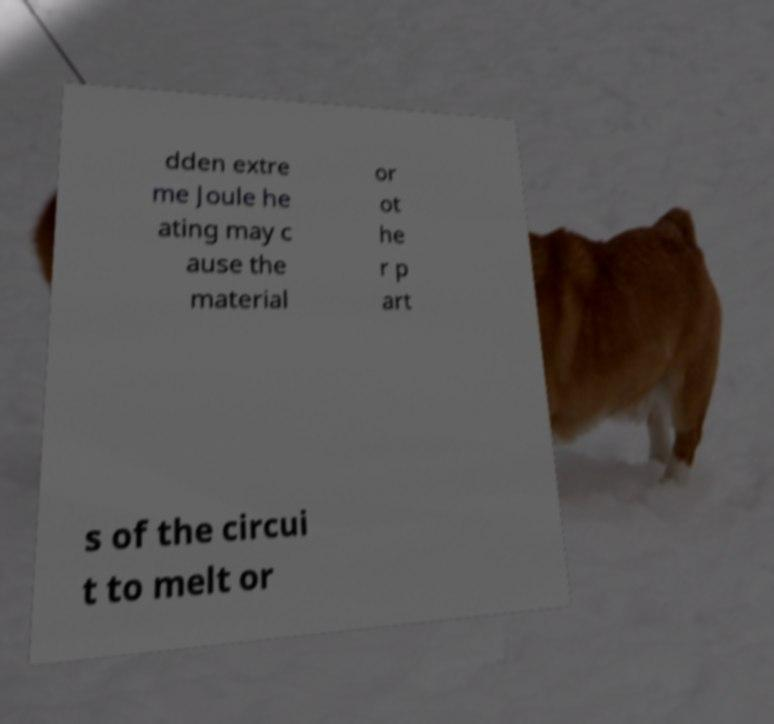For documentation purposes, I need the text within this image transcribed. Could you provide that? dden extre me Joule he ating may c ause the material or ot he r p art s of the circui t to melt or 